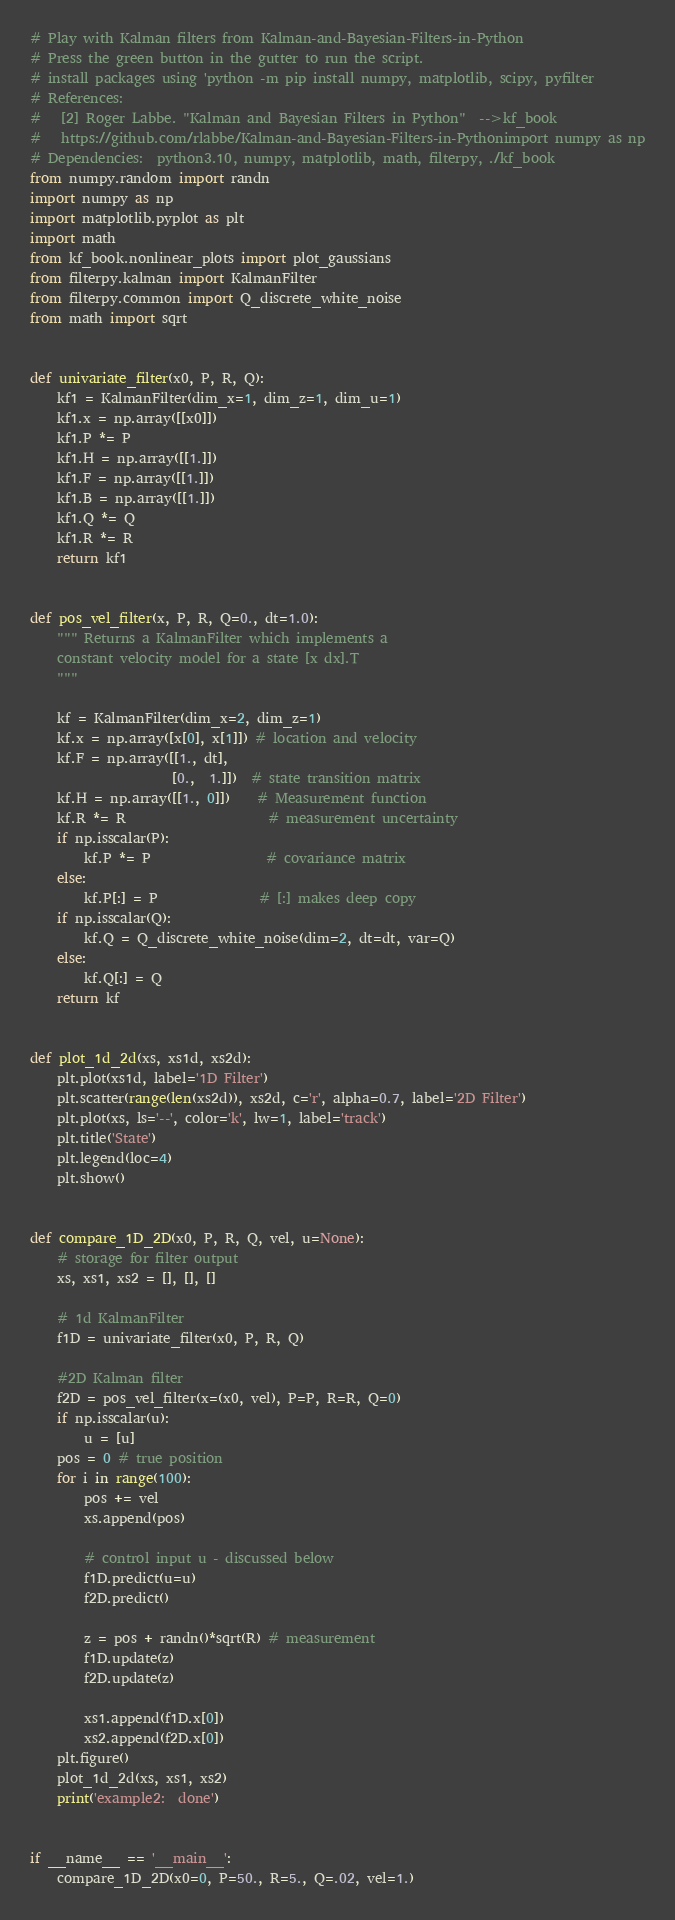Convert code to text. <code><loc_0><loc_0><loc_500><loc_500><_Python_># Play with Kalman filters from Kalman-and-Bayesian-Filters-in-Python
# Press the green button in the gutter to run the script.
# install packages using 'python -m pip install numpy, matplotlib, scipy, pyfilter
# References:
#   [2] Roger Labbe. "Kalman and Bayesian Filters in Python"  -->kf_book
#   https://github.com/rlabbe/Kalman-and-Bayesian-Filters-in-Pythonimport numpy as np
# Dependencies:  python3.10, numpy, matplotlib, math, filterpy, ./kf_book
from numpy.random import randn
import numpy as np
import matplotlib.pyplot as plt
import math
from kf_book.nonlinear_plots import plot_gaussians
from filterpy.kalman import KalmanFilter
from filterpy.common import Q_discrete_white_noise
from math import sqrt


def univariate_filter(x0, P, R, Q):
    kf1 = KalmanFilter(dim_x=1, dim_z=1, dim_u=1)
    kf1.x = np.array([[x0]])
    kf1.P *= P
    kf1.H = np.array([[1.]])
    kf1.F = np.array([[1.]])
    kf1.B = np.array([[1.]])
    kf1.Q *= Q
    kf1.R *= R
    return kf1


def pos_vel_filter(x, P, R, Q=0., dt=1.0):
    """ Returns a KalmanFilter which implements a
    constant velocity model for a state [x dx].T
    """
    
    kf = KalmanFilter(dim_x=2, dim_z=1)
    kf.x = np.array([x[0], x[1]]) # location and velocity
    kf.F = np.array([[1., dt],
                     [0.,  1.]])  # state transition matrix
    kf.H = np.array([[1., 0]])    # Measurement function
    kf.R *= R                     # measurement uncertainty
    if np.isscalar(P):
        kf.P *= P                 # covariance matrix 
    else:
        kf.P[:] = P               # [:] makes deep copy
    if np.isscalar(Q):
        kf.Q = Q_discrete_white_noise(dim=2, dt=dt, var=Q)
    else:
        kf.Q[:] = Q
    return kf


def plot_1d_2d(xs, xs1d, xs2d):
    plt.plot(xs1d, label='1D Filter')
    plt.scatter(range(len(xs2d)), xs2d, c='r', alpha=0.7, label='2D Filter')
    plt.plot(xs, ls='--', color='k', lw=1, label='track')
    plt.title('State')
    plt.legend(loc=4)
    plt.show()

    
def compare_1D_2D(x0, P, R, Q, vel, u=None):
    # storage for filter output
    xs, xs1, xs2 = [], [], []

    # 1d KalmanFilter
    f1D = univariate_filter(x0, P, R, Q)

    #2D Kalman filter
    f2D = pos_vel_filter(x=(x0, vel), P=P, R=R, Q=0)
    if np.isscalar(u):
        u = [u]
    pos = 0 # true position
    for i in range(100):
        pos += vel
        xs.append(pos)

        # control input u - discussed below
        f1D.predict(u=u)
        f2D.predict()
        
        z = pos + randn()*sqrt(R) # measurement
        f1D.update(z)
        f2D.update(z)
        
        xs1.append(f1D.x[0])
        xs2.append(f2D.x[0])
    plt.figure()
    plot_1d_2d(xs, xs1, xs2)
    print('example2:  done')


if __name__ == '__main__':
    compare_1D_2D(x0=0, P=50., R=5., Q=.02, vel=1.)
</code> 